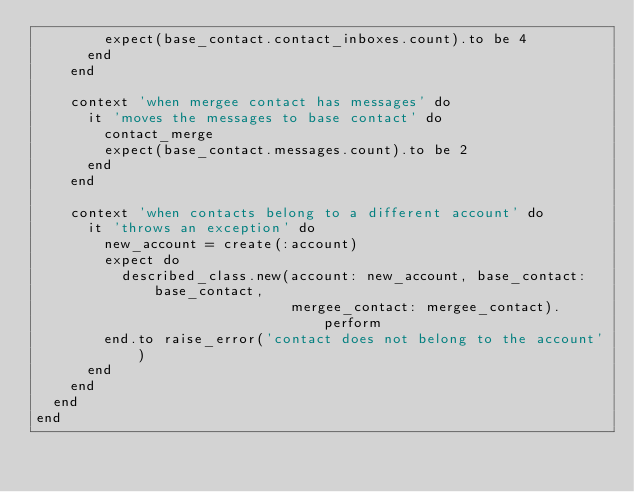Convert code to text. <code><loc_0><loc_0><loc_500><loc_500><_Ruby_>        expect(base_contact.contact_inboxes.count).to be 4
      end
    end

    context 'when mergee contact has messages' do
      it 'moves the messages to base contact' do
        contact_merge
        expect(base_contact.messages.count).to be 2
      end
    end

    context 'when contacts belong to a different account' do
      it 'throws an exception' do
        new_account = create(:account)
        expect do
          described_class.new(account: new_account, base_contact: base_contact,
                              mergee_contact: mergee_contact).perform
        end.to raise_error('contact does not belong to the account')
      end
    end
  end
end
</code> 